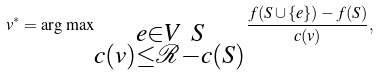<formula> <loc_0><loc_0><loc_500><loc_500>v ^ { * } = { \arg \, \max } _ { \substack { e \in V \ S \\ c ( v ) \leq \mathcal { R } - c ( S ) } } \frac { f ( S \cup \{ e \} ) - f ( S ) } { c ( v ) } ,</formula> 